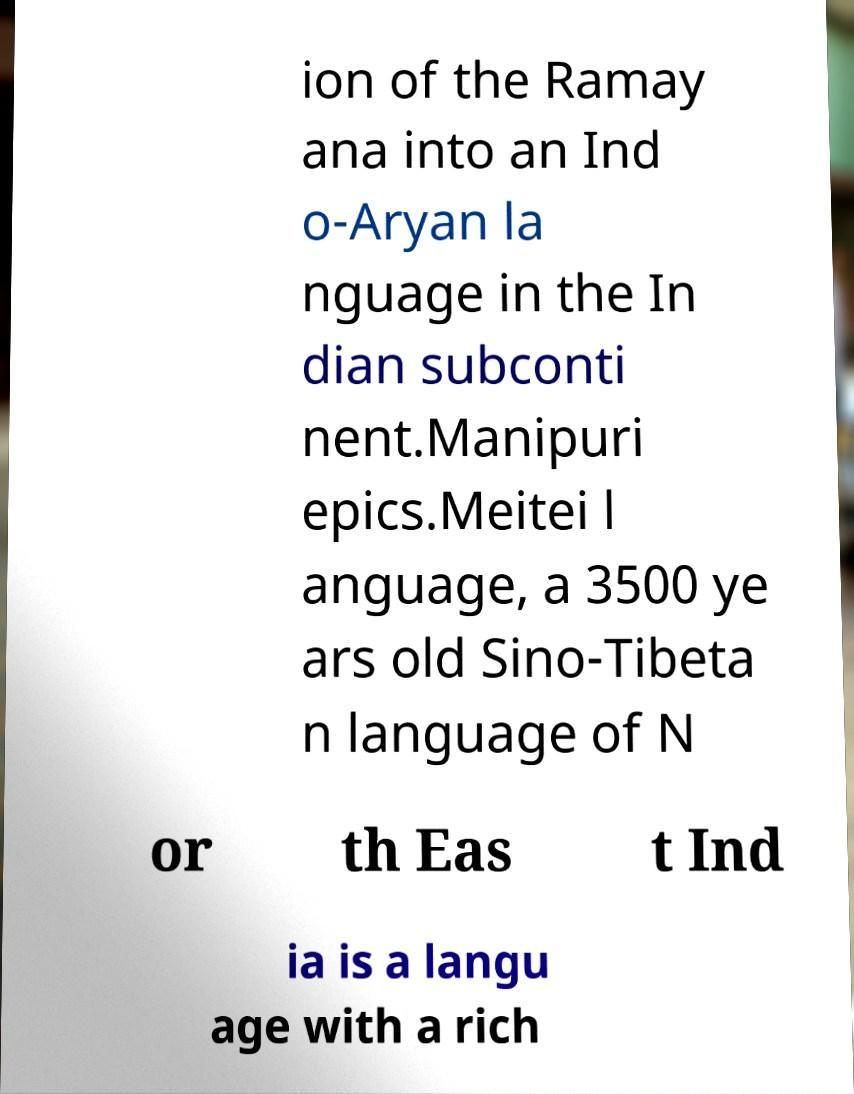Can you read and provide the text displayed in the image?This photo seems to have some interesting text. Can you extract and type it out for me? ion of the Ramay ana into an Ind o-Aryan la nguage in the In dian subconti nent.Manipuri epics.Meitei l anguage, a 3500 ye ars old Sino-Tibeta n language of N or th Eas t Ind ia is a langu age with a rich 